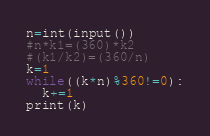<code> <loc_0><loc_0><loc_500><loc_500><_Python_>n=int(input())
#n*k1=(360)*k2
#(k1/k2)=(360/n)
k=1
while((k*n)%360!=0):
  k+=1
print(k)</code> 